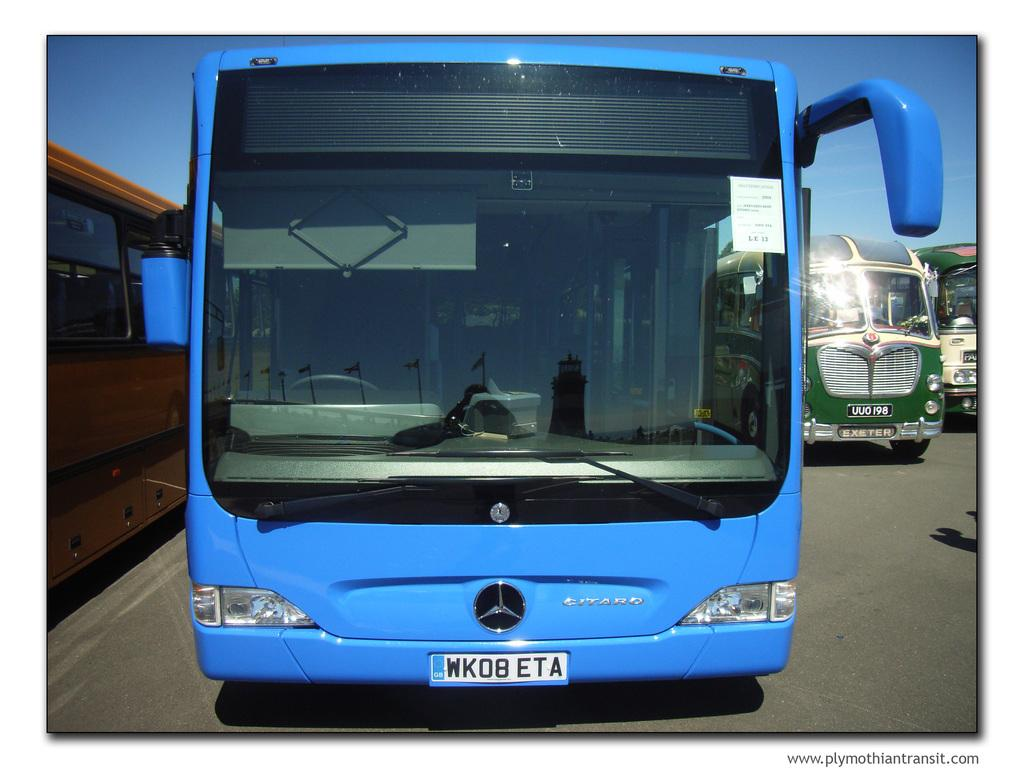Provide a one-sentence caption for the provided image. The blue Citaro bus' license plate reads WK08ETA. 